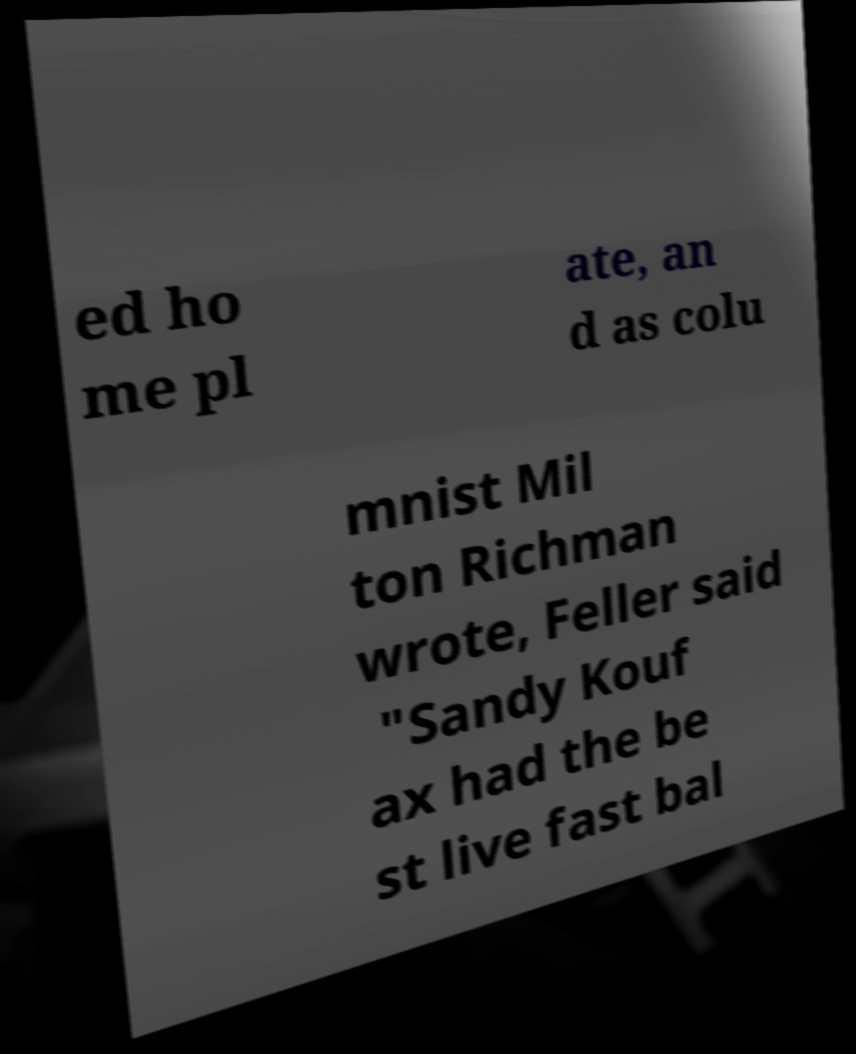I need the written content from this picture converted into text. Can you do that? ed ho me pl ate, an d as colu mnist Mil ton Richman wrote, Feller said "Sandy Kouf ax had the be st live fast bal 